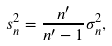<formula> <loc_0><loc_0><loc_500><loc_500>s _ { n } ^ { 2 } = { \frac { n ^ { \prime } } { n ^ { \prime } - 1 } } \sigma _ { n } ^ { 2 } ,</formula> 